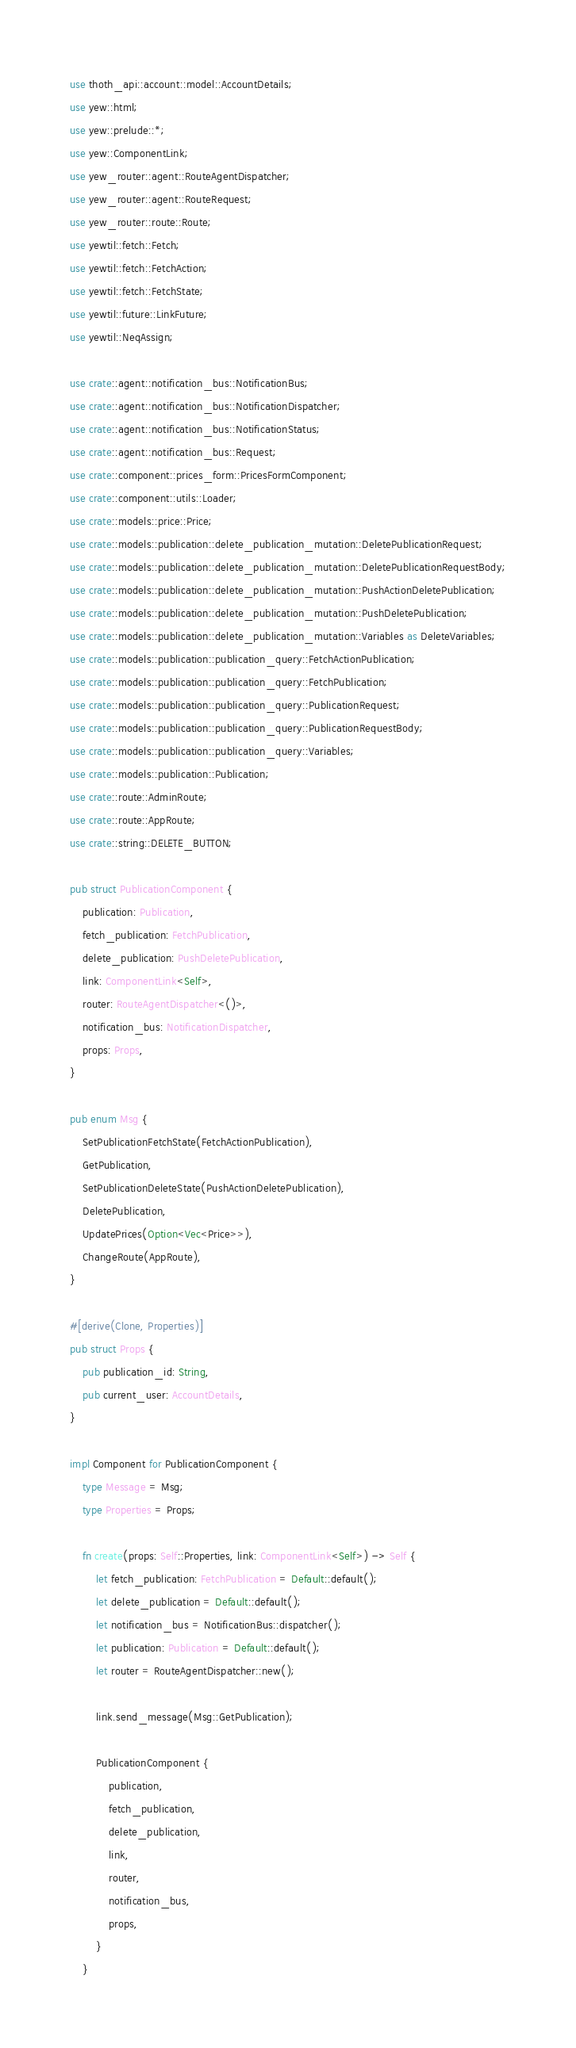<code> <loc_0><loc_0><loc_500><loc_500><_Rust_>use thoth_api::account::model::AccountDetails;
use yew::html;
use yew::prelude::*;
use yew::ComponentLink;
use yew_router::agent::RouteAgentDispatcher;
use yew_router::agent::RouteRequest;
use yew_router::route::Route;
use yewtil::fetch::Fetch;
use yewtil::fetch::FetchAction;
use yewtil::fetch::FetchState;
use yewtil::future::LinkFuture;
use yewtil::NeqAssign;

use crate::agent::notification_bus::NotificationBus;
use crate::agent::notification_bus::NotificationDispatcher;
use crate::agent::notification_bus::NotificationStatus;
use crate::agent::notification_bus::Request;
use crate::component::prices_form::PricesFormComponent;
use crate::component::utils::Loader;
use crate::models::price::Price;
use crate::models::publication::delete_publication_mutation::DeletePublicationRequest;
use crate::models::publication::delete_publication_mutation::DeletePublicationRequestBody;
use crate::models::publication::delete_publication_mutation::PushActionDeletePublication;
use crate::models::publication::delete_publication_mutation::PushDeletePublication;
use crate::models::publication::delete_publication_mutation::Variables as DeleteVariables;
use crate::models::publication::publication_query::FetchActionPublication;
use crate::models::publication::publication_query::FetchPublication;
use crate::models::publication::publication_query::PublicationRequest;
use crate::models::publication::publication_query::PublicationRequestBody;
use crate::models::publication::publication_query::Variables;
use crate::models::publication::Publication;
use crate::route::AdminRoute;
use crate::route::AppRoute;
use crate::string::DELETE_BUTTON;

pub struct PublicationComponent {
    publication: Publication,
    fetch_publication: FetchPublication,
    delete_publication: PushDeletePublication,
    link: ComponentLink<Self>,
    router: RouteAgentDispatcher<()>,
    notification_bus: NotificationDispatcher,
    props: Props,
}

pub enum Msg {
    SetPublicationFetchState(FetchActionPublication),
    GetPublication,
    SetPublicationDeleteState(PushActionDeletePublication),
    DeletePublication,
    UpdatePrices(Option<Vec<Price>>),
    ChangeRoute(AppRoute),
}

#[derive(Clone, Properties)]
pub struct Props {
    pub publication_id: String,
    pub current_user: AccountDetails,
}

impl Component for PublicationComponent {
    type Message = Msg;
    type Properties = Props;

    fn create(props: Self::Properties, link: ComponentLink<Self>) -> Self {
        let fetch_publication: FetchPublication = Default::default();
        let delete_publication = Default::default();
        let notification_bus = NotificationBus::dispatcher();
        let publication: Publication = Default::default();
        let router = RouteAgentDispatcher::new();

        link.send_message(Msg::GetPublication);

        PublicationComponent {
            publication,
            fetch_publication,
            delete_publication,
            link,
            router,
            notification_bus,
            props,
        }
    }
</code> 